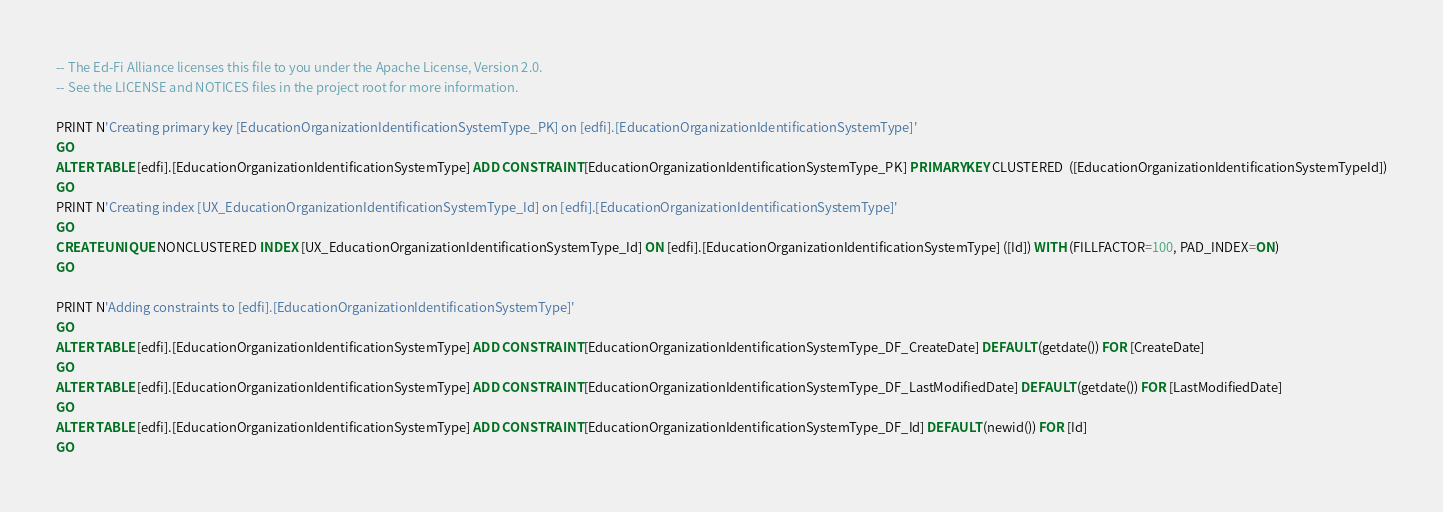<code> <loc_0><loc_0><loc_500><loc_500><_SQL_>-- The Ed-Fi Alliance licenses this file to you under the Apache License, Version 2.0.
-- See the LICENSE and NOTICES files in the project root for more information.

PRINT N'Creating primary key [EducationOrganizationIdentificationSystemType_PK] on [edfi].[EducationOrganizationIdentificationSystemType]'
GO
ALTER TABLE [edfi].[EducationOrganizationIdentificationSystemType] ADD CONSTRAINT [EducationOrganizationIdentificationSystemType_PK] PRIMARY KEY CLUSTERED  ([EducationOrganizationIdentificationSystemTypeId])
GO
PRINT N'Creating index [UX_EducationOrganizationIdentificationSystemType_Id] on [edfi].[EducationOrganizationIdentificationSystemType]'
GO
CREATE UNIQUE NONCLUSTERED INDEX [UX_EducationOrganizationIdentificationSystemType_Id] ON [edfi].[EducationOrganizationIdentificationSystemType] ([Id]) WITH (FILLFACTOR=100, PAD_INDEX=ON)
GO

PRINT N'Adding constraints to [edfi].[EducationOrganizationIdentificationSystemType]'
GO
ALTER TABLE [edfi].[EducationOrganizationIdentificationSystemType] ADD CONSTRAINT [EducationOrganizationIdentificationSystemType_DF_CreateDate] DEFAULT (getdate()) FOR [CreateDate]
GO
ALTER TABLE [edfi].[EducationOrganizationIdentificationSystemType] ADD CONSTRAINT [EducationOrganizationIdentificationSystemType_DF_LastModifiedDate] DEFAULT (getdate()) FOR [LastModifiedDate]
GO
ALTER TABLE [edfi].[EducationOrganizationIdentificationSystemType] ADD CONSTRAINT [EducationOrganizationIdentificationSystemType_DF_Id] DEFAULT (newid()) FOR [Id]
GO

</code> 